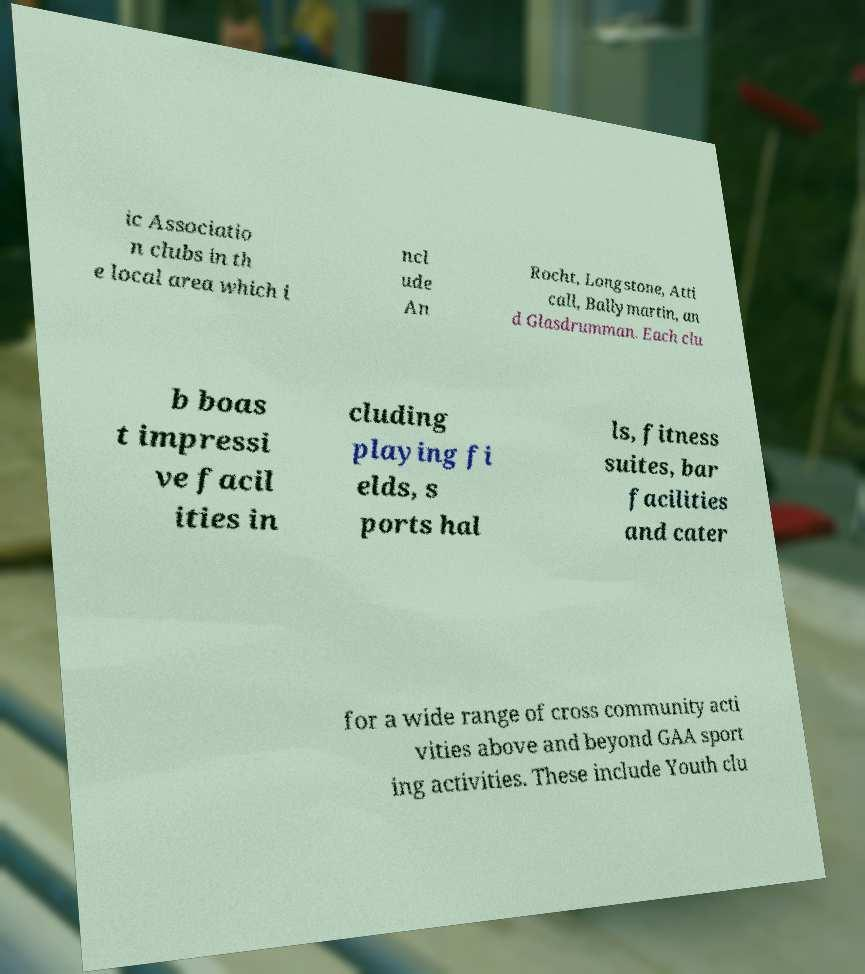Could you assist in decoding the text presented in this image and type it out clearly? ic Associatio n clubs in th e local area which i ncl ude An Rocht, Longstone, Atti call, Ballymartin, an d Glasdrumman. Each clu b boas t impressi ve facil ities in cluding playing fi elds, s ports hal ls, fitness suites, bar facilities and cater for a wide range of cross community acti vities above and beyond GAA sport ing activities. These include Youth clu 